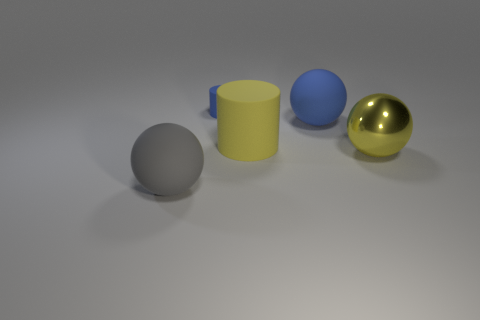The matte object that is on the right side of the big yellow rubber cylinder has what shape?
Keep it short and to the point. Sphere. Are there any big shiny things on the left side of the blue cylinder?
Make the answer very short. No. Is there any other thing that is the same size as the metallic object?
Offer a terse response. Yes. What color is the other cylinder that is made of the same material as the large yellow cylinder?
Ensure brevity in your answer.  Blue. Is the color of the big sphere that is left of the large blue thing the same as the big matte sphere on the right side of the big gray sphere?
Your answer should be compact. No. How many cubes are either small blue rubber things or big yellow matte objects?
Your answer should be very brief. 0. Are there the same number of blue matte cylinders in front of the gray sphere and big yellow rubber cylinders?
Your response must be concise. No. The ball behind the matte cylinder in front of the object behind the large blue rubber object is made of what material?
Keep it short and to the point. Rubber. There is a object that is the same color as the metal sphere; what material is it?
Ensure brevity in your answer.  Rubber. What number of things are things in front of the tiny rubber thing or yellow balls?
Keep it short and to the point. 4. 